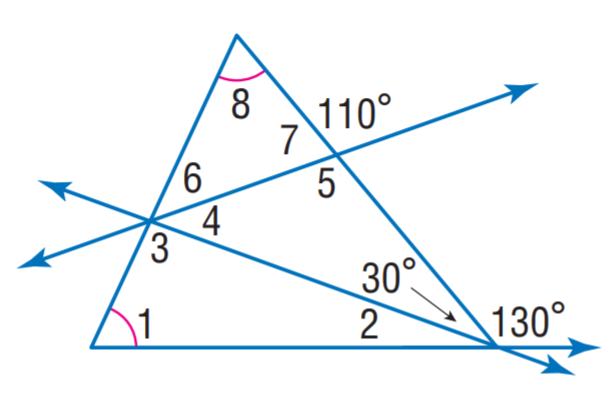Answer the mathemtical geometry problem and directly provide the correct option letter.
Question: Find m \angle 4.
Choices: A: 20 B: 30 C: 40 D: 65 C 